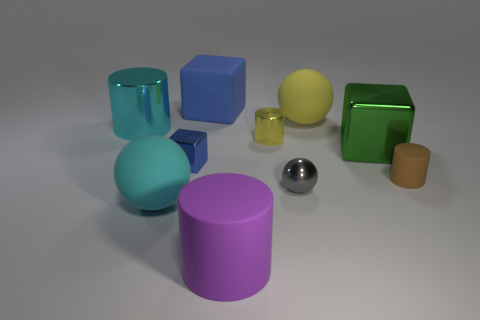There is a big object that is the same color as the small metallic block; what material is it?
Provide a short and direct response. Rubber. What number of tiny shiny objects have the same shape as the large purple rubber thing?
Your answer should be compact. 1. What is the shape of the big yellow rubber thing?
Keep it short and to the point. Sphere. Is the number of large green metal objects less than the number of spheres?
Your response must be concise. Yes. There is a large blue object that is the same shape as the big green metallic thing; what is it made of?
Provide a succinct answer. Rubber. Are there more large metal cubes than small purple spheres?
Offer a terse response. Yes. What number of other things are the same color as the big shiny cylinder?
Your response must be concise. 1. Do the tiny brown cylinder and the ball that is behind the large cyan shiny thing have the same material?
Provide a short and direct response. Yes. How many big cylinders are behind the small thing in front of the rubber cylinder that is right of the tiny shiny ball?
Keep it short and to the point. 1. Are there fewer brown things behind the green metallic object than brown cylinders on the right side of the small ball?
Provide a succinct answer. Yes. 